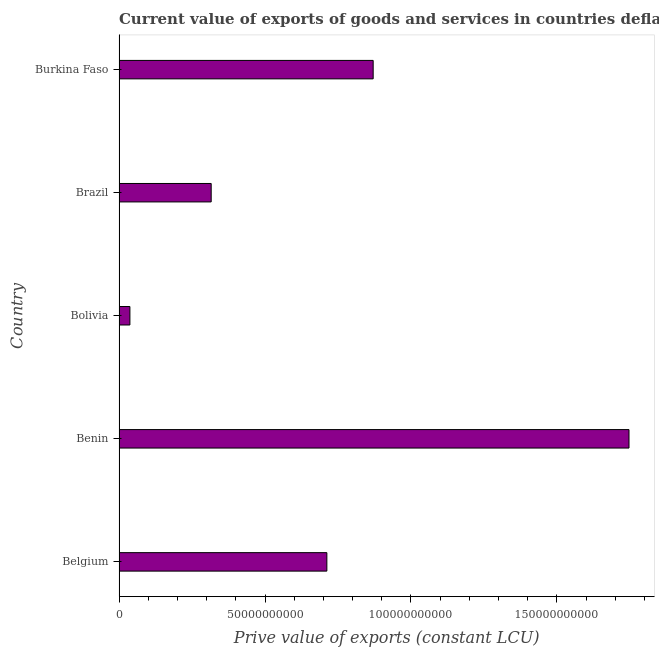Does the graph contain grids?
Provide a succinct answer. No. What is the title of the graph?
Ensure brevity in your answer.  Current value of exports of goods and services in countries deflated by the import price index. What is the label or title of the X-axis?
Give a very brief answer. Prive value of exports (constant LCU). What is the price value of exports in Bolivia?
Your answer should be very brief. 3.72e+09. Across all countries, what is the maximum price value of exports?
Give a very brief answer. 1.75e+11. Across all countries, what is the minimum price value of exports?
Provide a succinct answer. 3.72e+09. In which country was the price value of exports maximum?
Ensure brevity in your answer.  Benin. What is the sum of the price value of exports?
Your answer should be very brief. 3.68e+11. What is the difference between the price value of exports in Bolivia and Burkina Faso?
Offer a terse response. -8.33e+1. What is the average price value of exports per country?
Your answer should be very brief. 7.36e+1. What is the median price value of exports?
Your answer should be compact. 7.12e+1. What is the ratio of the price value of exports in Belgium to that in Benin?
Ensure brevity in your answer.  0.41. Is the price value of exports in Belgium less than that in Benin?
Offer a very short reply. Yes. What is the difference between the highest and the second highest price value of exports?
Your answer should be compact. 8.76e+1. What is the difference between the highest and the lowest price value of exports?
Make the answer very short. 1.71e+11. In how many countries, is the price value of exports greater than the average price value of exports taken over all countries?
Keep it short and to the point. 2. How many bars are there?
Offer a very short reply. 5. How many countries are there in the graph?
Provide a short and direct response. 5. Are the values on the major ticks of X-axis written in scientific E-notation?
Ensure brevity in your answer.  No. What is the Prive value of exports (constant LCU) in Belgium?
Your answer should be compact. 7.12e+1. What is the Prive value of exports (constant LCU) in Benin?
Offer a very short reply. 1.75e+11. What is the Prive value of exports (constant LCU) of Bolivia?
Give a very brief answer. 3.72e+09. What is the Prive value of exports (constant LCU) in Brazil?
Offer a very short reply. 3.16e+1. What is the Prive value of exports (constant LCU) of Burkina Faso?
Ensure brevity in your answer.  8.70e+1. What is the difference between the Prive value of exports (constant LCU) in Belgium and Benin?
Offer a terse response. -1.03e+11. What is the difference between the Prive value of exports (constant LCU) in Belgium and Bolivia?
Give a very brief answer. 6.75e+1. What is the difference between the Prive value of exports (constant LCU) in Belgium and Brazil?
Your response must be concise. 3.96e+1. What is the difference between the Prive value of exports (constant LCU) in Belgium and Burkina Faso?
Keep it short and to the point. -1.59e+1. What is the difference between the Prive value of exports (constant LCU) in Benin and Bolivia?
Keep it short and to the point. 1.71e+11. What is the difference between the Prive value of exports (constant LCU) in Benin and Brazil?
Ensure brevity in your answer.  1.43e+11. What is the difference between the Prive value of exports (constant LCU) in Benin and Burkina Faso?
Give a very brief answer. 8.76e+1. What is the difference between the Prive value of exports (constant LCU) in Bolivia and Brazil?
Provide a short and direct response. -2.78e+1. What is the difference between the Prive value of exports (constant LCU) in Bolivia and Burkina Faso?
Your response must be concise. -8.33e+1. What is the difference between the Prive value of exports (constant LCU) in Brazil and Burkina Faso?
Give a very brief answer. -5.55e+1. What is the ratio of the Prive value of exports (constant LCU) in Belgium to that in Benin?
Provide a succinct answer. 0.41. What is the ratio of the Prive value of exports (constant LCU) in Belgium to that in Bolivia?
Ensure brevity in your answer.  19.16. What is the ratio of the Prive value of exports (constant LCU) in Belgium to that in Brazil?
Your answer should be compact. 2.25. What is the ratio of the Prive value of exports (constant LCU) in Belgium to that in Burkina Faso?
Your response must be concise. 0.82. What is the ratio of the Prive value of exports (constant LCU) in Benin to that in Bolivia?
Provide a succinct answer. 47.01. What is the ratio of the Prive value of exports (constant LCU) in Benin to that in Brazil?
Provide a short and direct response. 5.54. What is the ratio of the Prive value of exports (constant LCU) in Benin to that in Burkina Faso?
Provide a short and direct response. 2.01. What is the ratio of the Prive value of exports (constant LCU) in Bolivia to that in Brazil?
Provide a short and direct response. 0.12. What is the ratio of the Prive value of exports (constant LCU) in Bolivia to that in Burkina Faso?
Your answer should be very brief. 0.04. What is the ratio of the Prive value of exports (constant LCU) in Brazil to that in Burkina Faso?
Make the answer very short. 0.36. 